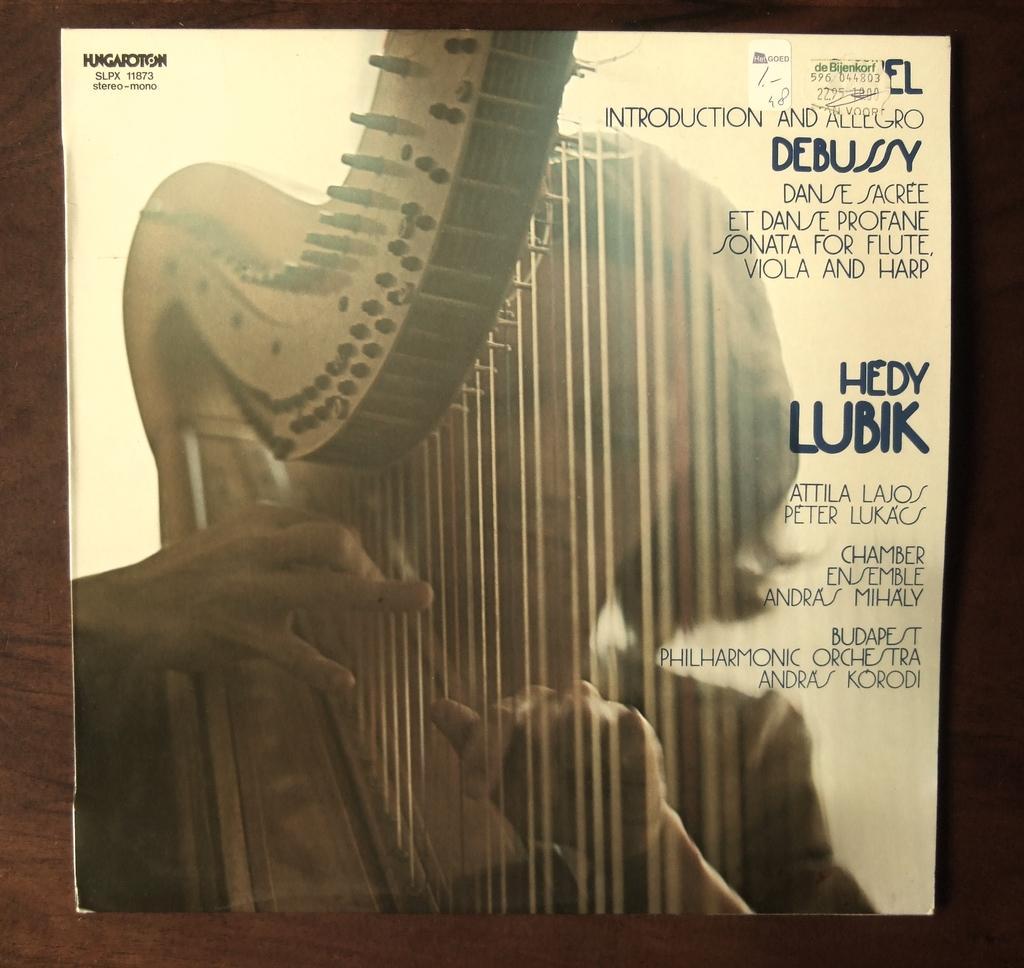Can you describe this image briefly? This is an edited image in which there is a woman holding a musical instrument and there is some text written on it. 